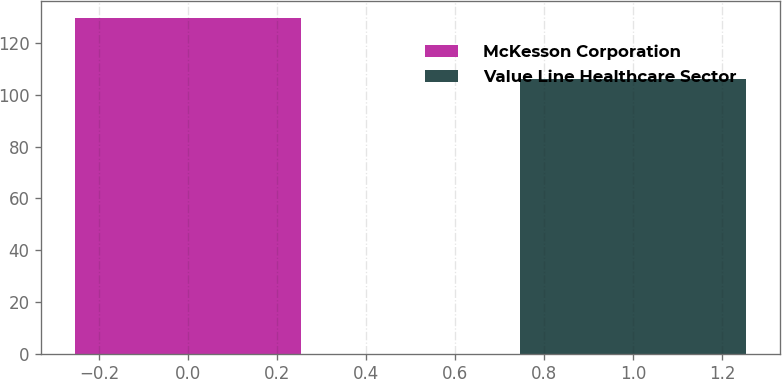<chart> <loc_0><loc_0><loc_500><loc_500><bar_chart><fcel>McKesson Corporation<fcel>Value Line Healthcare Sector<nl><fcel>129.66<fcel>106.21<nl></chart> 